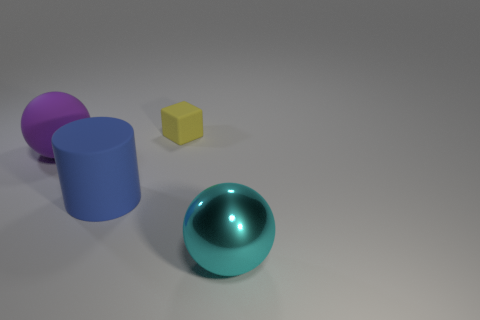Is there any other thing that is the same material as the large purple object?
Keep it short and to the point. Yes. What is the thing that is in front of the yellow block and on the right side of the blue thing made of?
Make the answer very short. Metal. What is the shape of the small object that is the same material as the large cylinder?
Your answer should be compact. Cube. Is the number of large objects left of the large cyan shiny thing greater than the number of large cyan cubes?
Provide a short and direct response. Yes. What material is the large cyan object?
Make the answer very short. Metal. How many cyan things have the same size as the cyan metallic sphere?
Your answer should be very brief. 0. Is the number of purple rubber things that are behind the small object the same as the number of matte cubes that are in front of the big blue cylinder?
Offer a terse response. Yes. Does the cyan sphere have the same material as the cylinder?
Your answer should be compact. No. There is a big sphere behind the blue thing; is there a small yellow rubber block that is to the right of it?
Ensure brevity in your answer.  Yes. Are there any other shiny things that have the same shape as the big purple object?
Offer a terse response. Yes. 